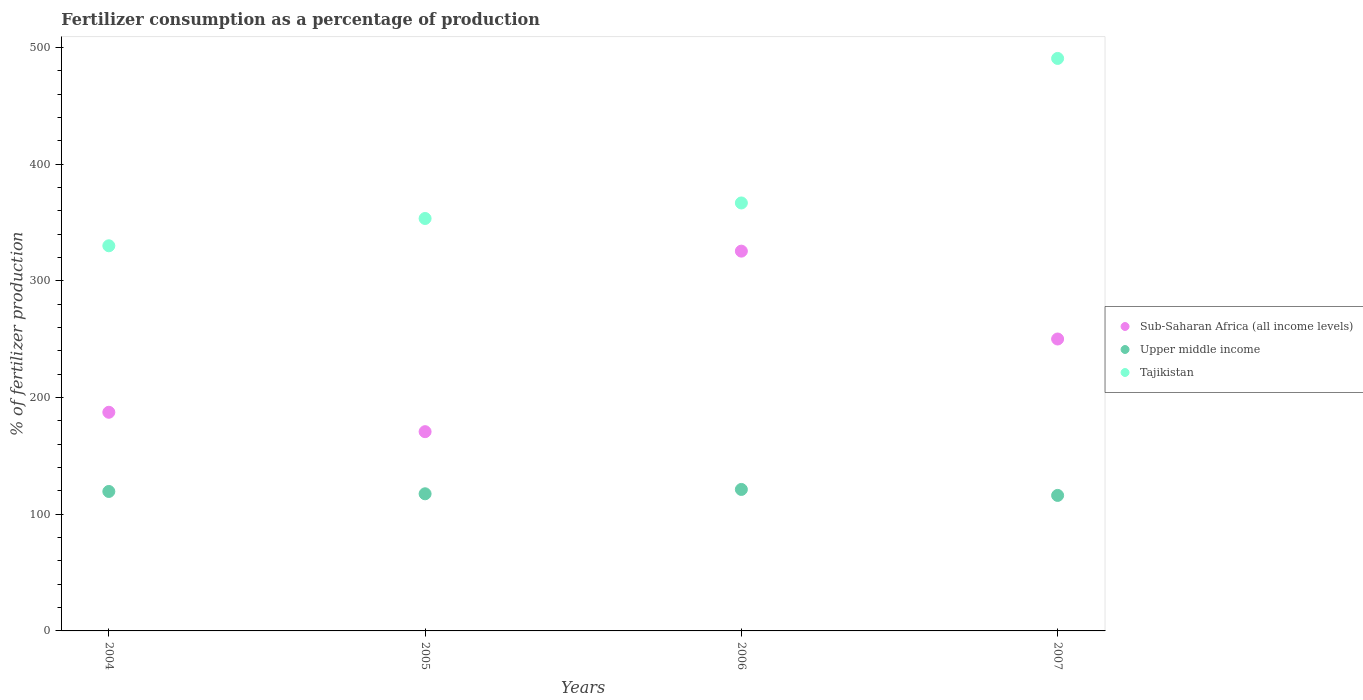Is the number of dotlines equal to the number of legend labels?
Your answer should be very brief. Yes. What is the percentage of fertilizers consumed in Upper middle income in 2004?
Offer a terse response. 119.53. Across all years, what is the maximum percentage of fertilizers consumed in Upper middle income?
Make the answer very short. 121.26. Across all years, what is the minimum percentage of fertilizers consumed in Sub-Saharan Africa (all income levels)?
Provide a short and direct response. 170.78. In which year was the percentage of fertilizers consumed in Sub-Saharan Africa (all income levels) maximum?
Your answer should be compact. 2006. What is the total percentage of fertilizers consumed in Upper middle income in the graph?
Your answer should be very brief. 474.46. What is the difference between the percentage of fertilizers consumed in Upper middle income in 2004 and that in 2006?
Ensure brevity in your answer.  -1.73. What is the difference between the percentage of fertilizers consumed in Upper middle income in 2004 and the percentage of fertilizers consumed in Sub-Saharan Africa (all income levels) in 2007?
Provide a short and direct response. -130.67. What is the average percentage of fertilizers consumed in Tajikistan per year?
Keep it short and to the point. 385.27. In the year 2005, what is the difference between the percentage of fertilizers consumed in Sub-Saharan Africa (all income levels) and percentage of fertilizers consumed in Upper middle income?
Your response must be concise. 53.24. In how many years, is the percentage of fertilizers consumed in Tajikistan greater than 360 %?
Your answer should be compact. 2. What is the ratio of the percentage of fertilizers consumed in Sub-Saharan Africa (all income levels) in 2004 to that in 2007?
Your answer should be compact. 0.75. Is the difference between the percentage of fertilizers consumed in Sub-Saharan Africa (all income levels) in 2005 and 2007 greater than the difference between the percentage of fertilizers consumed in Upper middle income in 2005 and 2007?
Your answer should be compact. No. What is the difference between the highest and the second highest percentage of fertilizers consumed in Sub-Saharan Africa (all income levels)?
Make the answer very short. 75.31. What is the difference between the highest and the lowest percentage of fertilizers consumed in Tajikistan?
Provide a succinct answer. 160.58. Does the percentage of fertilizers consumed in Tajikistan monotonically increase over the years?
Provide a short and direct response. Yes. Is the percentage of fertilizers consumed in Upper middle income strictly greater than the percentage of fertilizers consumed in Sub-Saharan Africa (all income levels) over the years?
Offer a very short reply. No. How many dotlines are there?
Make the answer very short. 3. How many years are there in the graph?
Offer a very short reply. 4. How many legend labels are there?
Give a very brief answer. 3. What is the title of the graph?
Give a very brief answer. Fertilizer consumption as a percentage of production. Does "Europe(all income levels)" appear as one of the legend labels in the graph?
Give a very brief answer. No. What is the label or title of the Y-axis?
Your answer should be compact. % of fertilizer production. What is the % of fertilizer production of Sub-Saharan Africa (all income levels) in 2004?
Offer a very short reply. 187.4. What is the % of fertilizer production in Upper middle income in 2004?
Provide a succinct answer. 119.53. What is the % of fertilizer production in Tajikistan in 2004?
Offer a terse response. 330.1. What is the % of fertilizer production in Sub-Saharan Africa (all income levels) in 2005?
Make the answer very short. 170.78. What is the % of fertilizer production in Upper middle income in 2005?
Your answer should be compact. 117.53. What is the % of fertilizer production in Tajikistan in 2005?
Your answer should be compact. 353.49. What is the % of fertilizer production in Sub-Saharan Africa (all income levels) in 2006?
Offer a terse response. 325.51. What is the % of fertilizer production of Upper middle income in 2006?
Offer a terse response. 121.26. What is the % of fertilizer production in Tajikistan in 2006?
Your answer should be compact. 366.81. What is the % of fertilizer production of Sub-Saharan Africa (all income levels) in 2007?
Offer a very short reply. 250.2. What is the % of fertilizer production in Upper middle income in 2007?
Provide a short and direct response. 116.14. What is the % of fertilizer production in Tajikistan in 2007?
Provide a short and direct response. 490.68. Across all years, what is the maximum % of fertilizer production in Sub-Saharan Africa (all income levels)?
Your answer should be very brief. 325.51. Across all years, what is the maximum % of fertilizer production of Upper middle income?
Ensure brevity in your answer.  121.26. Across all years, what is the maximum % of fertilizer production of Tajikistan?
Your response must be concise. 490.68. Across all years, what is the minimum % of fertilizer production in Sub-Saharan Africa (all income levels)?
Your response must be concise. 170.78. Across all years, what is the minimum % of fertilizer production of Upper middle income?
Your answer should be very brief. 116.14. Across all years, what is the minimum % of fertilizer production of Tajikistan?
Provide a short and direct response. 330.1. What is the total % of fertilizer production of Sub-Saharan Africa (all income levels) in the graph?
Your answer should be compact. 933.89. What is the total % of fertilizer production of Upper middle income in the graph?
Ensure brevity in your answer.  474.46. What is the total % of fertilizer production in Tajikistan in the graph?
Provide a succinct answer. 1541.08. What is the difference between the % of fertilizer production in Sub-Saharan Africa (all income levels) in 2004 and that in 2005?
Offer a very short reply. 16.62. What is the difference between the % of fertilizer production in Upper middle income in 2004 and that in 2005?
Keep it short and to the point. 2. What is the difference between the % of fertilizer production in Tajikistan in 2004 and that in 2005?
Provide a succinct answer. -23.39. What is the difference between the % of fertilizer production in Sub-Saharan Africa (all income levels) in 2004 and that in 2006?
Provide a succinct answer. -138.11. What is the difference between the % of fertilizer production in Upper middle income in 2004 and that in 2006?
Ensure brevity in your answer.  -1.73. What is the difference between the % of fertilizer production of Tajikistan in 2004 and that in 2006?
Your response must be concise. -36.71. What is the difference between the % of fertilizer production of Sub-Saharan Africa (all income levels) in 2004 and that in 2007?
Your answer should be compact. -62.81. What is the difference between the % of fertilizer production in Upper middle income in 2004 and that in 2007?
Offer a very short reply. 3.39. What is the difference between the % of fertilizer production in Tajikistan in 2004 and that in 2007?
Offer a terse response. -160.58. What is the difference between the % of fertilizer production of Sub-Saharan Africa (all income levels) in 2005 and that in 2006?
Keep it short and to the point. -154.73. What is the difference between the % of fertilizer production of Upper middle income in 2005 and that in 2006?
Your response must be concise. -3.73. What is the difference between the % of fertilizer production in Tajikistan in 2005 and that in 2006?
Offer a very short reply. -13.31. What is the difference between the % of fertilizer production in Sub-Saharan Africa (all income levels) in 2005 and that in 2007?
Offer a terse response. -79.43. What is the difference between the % of fertilizer production in Upper middle income in 2005 and that in 2007?
Your answer should be very brief. 1.4. What is the difference between the % of fertilizer production in Tajikistan in 2005 and that in 2007?
Give a very brief answer. -137.19. What is the difference between the % of fertilizer production in Sub-Saharan Africa (all income levels) in 2006 and that in 2007?
Make the answer very short. 75.31. What is the difference between the % of fertilizer production in Upper middle income in 2006 and that in 2007?
Your answer should be very brief. 5.12. What is the difference between the % of fertilizer production of Tajikistan in 2006 and that in 2007?
Your response must be concise. -123.88. What is the difference between the % of fertilizer production of Sub-Saharan Africa (all income levels) in 2004 and the % of fertilizer production of Upper middle income in 2005?
Your response must be concise. 69.86. What is the difference between the % of fertilizer production in Sub-Saharan Africa (all income levels) in 2004 and the % of fertilizer production in Tajikistan in 2005?
Give a very brief answer. -166.1. What is the difference between the % of fertilizer production of Upper middle income in 2004 and the % of fertilizer production of Tajikistan in 2005?
Provide a succinct answer. -233.97. What is the difference between the % of fertilizer production of Sub-Saharan Africa (all income levels) in 2004 and the % of fertilizer production of Upper middle income in 2006?
Give a very brief answer. 66.13. What is the difference between the % of fertilizer production of Sub-Saharan Africa (all income levels) in 2004 and the % of fertilizer production of Tajikistan in 2006?
Offer a very short reply. -179.41. What is the difference between the % of fertilizer production in Upper middle income in 2004 and the % of fertilizer production in Tajikistan in 2006?
Offer a very short reply. -247.28. What is the difference between the % of fertilizer production in Sub-Saharan Africa (all income levels) in 2004 and the % of fertilizer production in Upper middle income in 2007?
Keep it short and to the point. 71.26. What is the difference between the % of fertilizer production in Sub-Saharan Africa (all income levels) in 2004 and the % of fertilizer production in Tajikistan in 2007?
Your answer should be very brief. -303.29. What is the difference between the % of fertilizer production in Upper middle income in 2004 and the % of fertilizer production in Tajikistan in 2007?
Make the answer very short. -371.15. What is the difference between the % of fertilizer production of Sub-Saharan Africa (all income levels) in 2005 and the % of fertilizer production of Upper middle income in 2006?
Provide a short and direct response. 49.52. What is the difference between the % of fertilizer production in Sub-Saharan Africa (all income levels) in 2005 and the % of fertilizer production in Tajikistan in 2006?
Give a very brief answer. -196.03. What is the difference between the % of fertilizer production of Upper middle income in 2005 and the % of fertilizer production of Tajikistan in 2006?
Give a very brief answer. -249.27. What is the difference between the % of fertilizer production in Sub-Saharan Africa (all income levels) in 2005 and the % of fertilizer production in Upper middle income in 2007?
Provide a short and direct response. 54.64. What is the difference between the % of fertilizer production of Sub-Saharan Africa (all income levels) in 2005 and the % of fertilizer production of Tajikistan in 2007?
Keep it short and to the point. -319.91. What is the difference between the % of fertilizer production of Upper middle income in 2005 and the % of fertilizer production of Tajikistan in 2007?
Your answer should be very brief. -373.15. What is the difference between the % of fertilizer production of Sub-Saharan Africa (all income levels) in 2006 and the % of fertilizer production of Upper middle income in 2007?
Offer a terse response. 209.37. What is the difference between the % of fertilizer production of Sub-Saharan Africa (all income levels) in 2006 and the % of fertilizer production of Tajikistan in 2007?
Your answer should be compact. -165.17. What is the difference between the % of fertilizer production in Upper middle income in 2006 and the % of fertilizer production in Tajikistan in 2007?
Give a very brief answer. -369.42. What is the average % of fertilizer production in Sub-Saharan Africa (all income levels) per year?
Keep it short and to the point. 233.47. What is the average % of fertilizer production in Upper middle income per year?
Offer a very short reply. 118.62. What is the average % of fertilizer production in Tajikistan per year?
Your answer should be compact. 385.27. In the year 2004, what is the difference between the % of fertilizer production in Sub-Saharan Africa (all income levels) and % of fertilizer production in Upper middle income?
Keep it short and to the point. 67.87. In the year 2004, what is the difference between the % of fertilizer production in Sub-Saharan Africa (all income levels) and % of fertilizer production in Tajikistan?
Offer a terse response. -142.7. In the year 2004, what is the difference between the % of fertilizer production in Upper middle income and % of fertilizer production in Tajikistan?
Make the answer very short. -210.57. In the year 2005, what is the difference between the % of fertilizer production of Sub-Saharan Africa (all income levels) and % of fertilizer production of Upper middle income?
Provide a short and direct response. 53.24. In the year 2005, what is the difference between the % of fertilizer production of Sub-Saharan Africa (all income levels) and % of fertilizer production of Tajikistan?
Your answer should be very brief. -182.72. In the year 2005, what is the difference between the % of fertilizer production in Upper middle income and % of fertilizer production in Tajikistan?
Your answer should be very brief. -235.96. In the year 2006, what is the difference between the % of fertilizer production in Sub-Saharan Africa (all income levels) and % of fertilizer production in Upper middle income?
Provide a succinct answer. 204.25. In the year 2006, what is the difference between the % of fertilizer production in Sub-Saharan Africa (all income levels) and % of fertilizer production in Tajikistan?
Make the answer very short. -41.3. In the year 2006, what is the difference between the % of fertilizer production of Upper middle income and % of fertilizer production of Tajikistan?
Your answer should be compact. -245.54. In the year 2007, what is the difference between the % of fertilizer production in Sub-Saharan Africa (all income levels) and % of fertilizer production in Upper middle income?
Keep it short and to the point. 134.06. In the year 2007, what is the difference between the % of fertilizer production in Sub-Saharan Africa (all income levels) and % of fertilizer production in Tajikistan?
Your response must be concise. -240.48. In the year 2007, what is the difference between the % of fertilizer production of Upper middle income and % of fertilizer production of Tajikistan?
Your answer should be compact. -374.55. What is the ratio of the % of fertilizer production of Sub-Saharan Africa (all income levels) in 2004 to that in 2005?
Offer a very short reply. 1.1. What is the ratio of the % of fertilizer production in Tajikistan in 2004 to that in 2005?
Ensure brevity in your answer.  0.93. What is the ratio of the % of fertilizer production in Sub-Saharan Africa (all income levels) in 2004 to that in 2006?
Make the answer very short. 0.58. What is the ratio of the % of fertilizer production of Upper middle income in 2004 to that in 2006?
Your answer should be very brief. 0.99. What is the ratio of the % of fertilizer production in Tajikistan in 2004 to that in 2006?
Offer a very short reply. 0.9. What is the ratio of the % of fertilizer production in Sub-Saharan Africa (all income levels) in 2004 to that in 2007?
Ensure brevity in your answer.  0.75. What is the ratio of the % of fertilizer production in Upper middle income in 2004 to that in 2007?
Your response must be concise. 1.03. What is the ratio of the % of fertilizer production in Tajikistan in 2004 to that in 2007?
Ensure brevity in your answer.  0.67. What is the ratio of the % of fertilizer production of Sub-Saharan Africa (all income levels) in 2005 to that in 2006?
Your answer should be very brief. 0.52. What is the ratio of the % of fertilizer production in Upper middle income in 2005 to that in 2006?
Keep it short and to the point. 0.97. What is the ratio of the % of fertilizer production in Tajikistan in 2005 to that in 2006?
Provide a succinct answer. 0.96. What is the ratio of the % of fertilizer production of Sub-Saharan Africa (all income levels) in 2005 to that in 2007?
Your answer should be very brief. 0.68. What is the ratio of the % of fertilizer production in Tajikistan in 2005 to that in 2007?
Keep it short and to the point. 0.72. What is the ratio of the % of fertilizer production in Sub-Saharan Africa (all income levels) in 2006 to that in 2007?
Offer a very short reply. 1.3. What is the ratio of the % of fertilizer production of Upper middle income in 2006 to that in 2007?
Offer a very short reply. 1.04. What is the ratio of the % of fertilizer production in Tajikistan in 2006 to that in 2007?
Make the answer very short. 0.75. What is the difference between the highest and the second highest % of fertilizer production in Sub-Saharan Africa (all income levels)?
Provide a succinct answer. 75.31. What is the difference between the highest and the second highest % of fertilizer production of Upper middle income?
Give a very brief answer. 1.73. What is the difference between the highest and the second highest % of fertilizer production of Tajikistan?
Your response must be concise. 123.88. What is the difference between the highest and the lowest % of fertilizer production in Sub-Saharan Africa (all income levels)?
Keep it short and to the point. 154.73. What is the difference between the highest and the lowest % of fertilizer production of Upper middle income?
Ensure brevity in your answer.  5.12. What is the difference between the highest and the lowest % of fertilizer production of Tajikistan?
Ensure brevity in your answer.  160.58. 